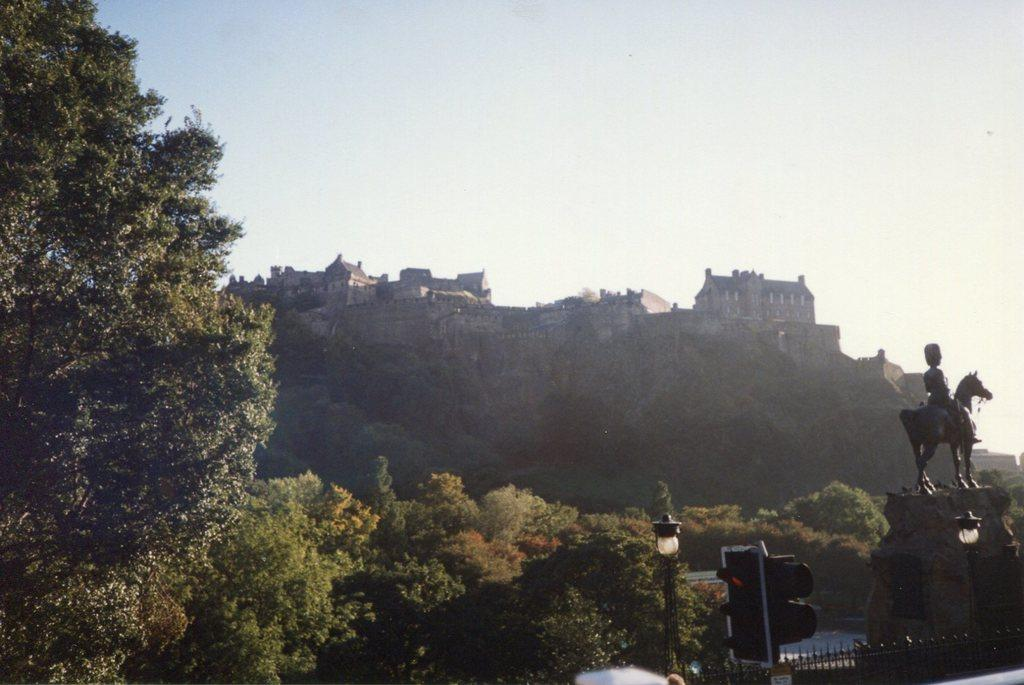What is the main subject on the pillar in the image? There is a sculpture on a pillar in the image. What type of structures can be seen in the image? There are buildings in the image. What other natural elements are present in the image? There are trees in the image. What type of artificial light source is visible in the image? There is a street light in the image. What other man-made structures can be seen in the image? There are light poles and a fence in the image. What part of the natural environment is visible in the image? The sky is visible in the image. How many beetles can be seen crawling on the sculpture in the image? There are no beetles visible on the sculpture in the image. What type of scale is used to measure the size of the sculpture in the image? There is no scale present in the image, and the size of the sculpture cannot be measured from the image alone. 